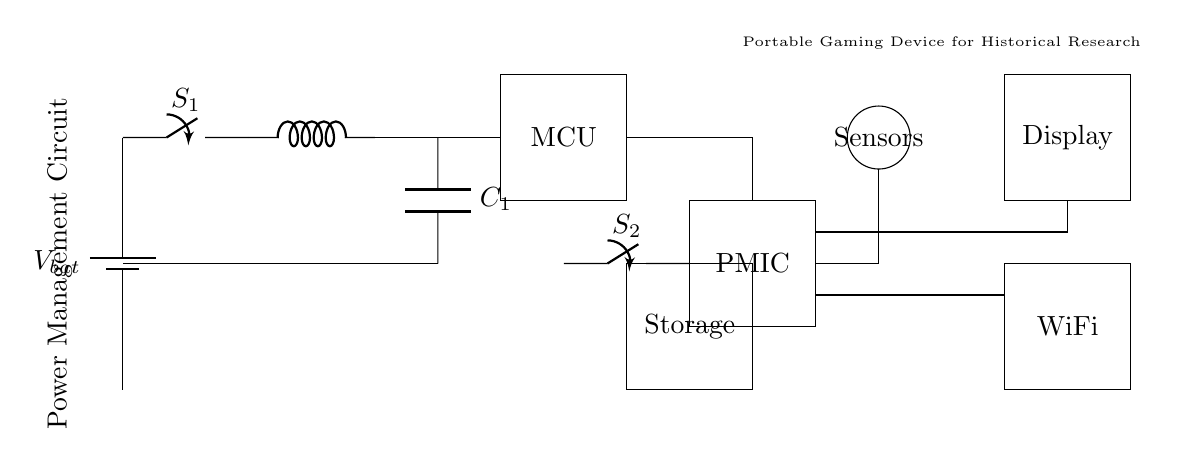What is the main function of the PMIC? The PMIC, or Power Management Integrated Circuit, regulates power distribution and efficiency for the device. It ensures optimal power usage across connected components like sensors and the display.
Answer: Power management What components are used for energy storage? The component that acts as energy storage in the circuit is the capacitor labeled C1, which helps in smoothing voltage spikes and providing a steady power supply.
Answer: Capacitor How many switches are there in the circuit? There are two switches in the circuit; S1 and S2 are used to control the flow of power to the main components of the device.
Answer: Two Which component connects the battery to the microcontroller? The main connection from the battery to the microcontroller is established through the inductor component, which regulates the current flow to the MCU.
Answer: Inductor Describe the function of the low-power mode switch. The low-power mode switch allows users to toggle between power states, extending battery life by reducing power consumption for non-essential components, effectively managing battery resources.
Answer: Battery life extension Where is the WiFi module positioned in relation to the other components? The WiFi module is positioned toward the bottom right of the circuit diagram, connected to the power management IC and adjacent to the display, indicating its role in power consumption management while communicating data.
Answer: Bottom right What role do the sensors play in the circuit? The sensors gather environmental data which is then processed by the microcontroller, allowing the device to operate efficiently by adjusting power usage based on external conditions.
Answer: Data collection 